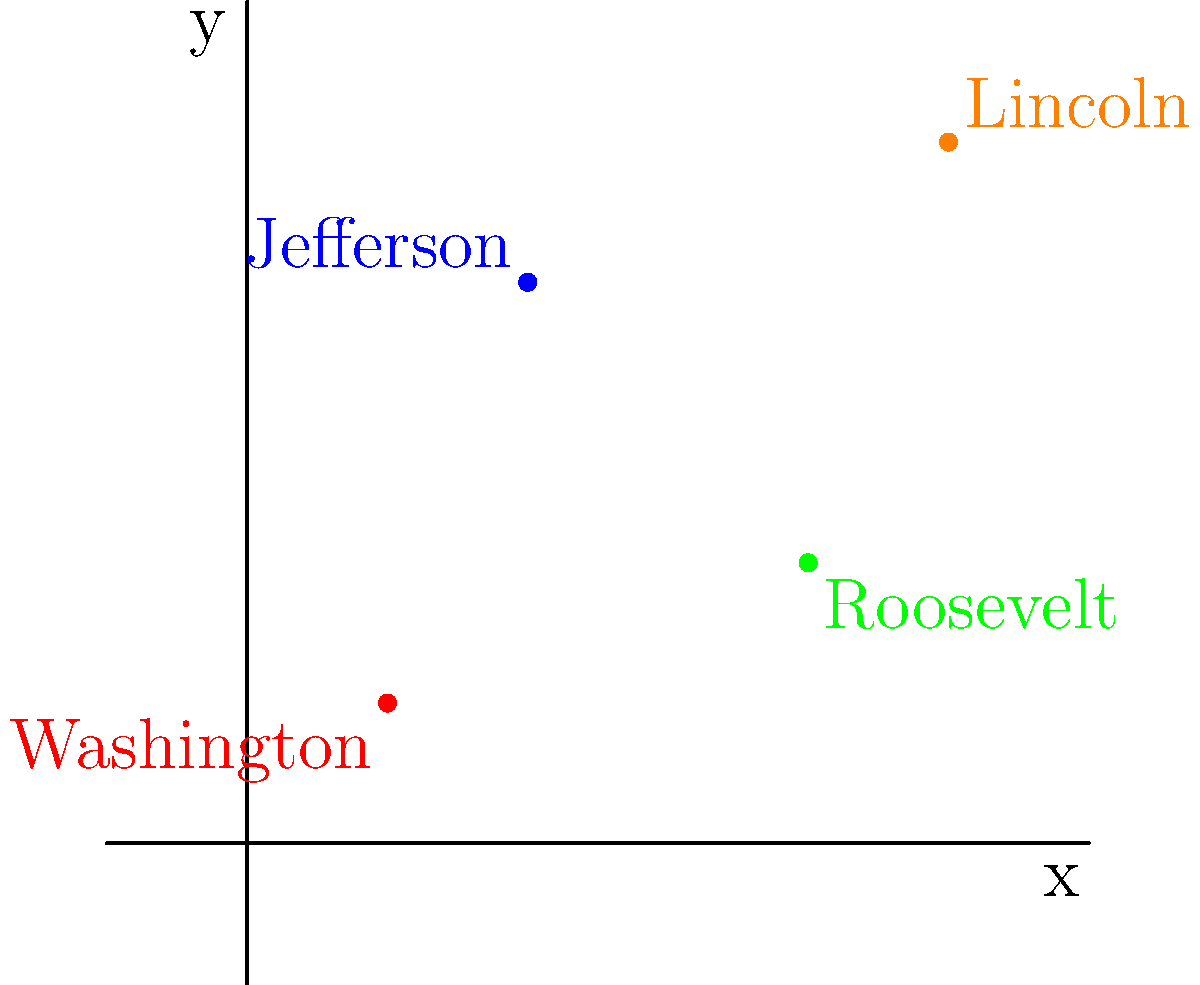In the coordinate system above, four points represent the faces on Mount Rushmore. What is the total distance between Washington's nose (1,1) and Lincoln's nose (5,5)? To find the distance between two points in a coordinate system, we can use the distance formula:

$d = \sqrt{(x_2 - x_1)^2 + (y_2 - y_1)^2}$

Where $(x_1, y_1)$ is the first point and $(x_2, y_2)$ is the second point.

Let's plug in our values:
$(x_1, y_1) = (1, 1)$ for Washington
$(x_2, y_2) = (5, 5)$ for Lincoln

Now, let's calculate:

1) $d = \sqrt{(5 - 1)^2 + (5 - 1)^2}$
2) $d = \sqrt{4^2 + 4^2}$
3) $d = \sqrt{16 + 16}$
4) $d = \sqrt{32}$
5) $d = 4\sqrt{2}$

Therefore, the distance between Washington's nose and Lincoln's nose is $4\sqrt{2}$ units.
Answer: $4\sqrt{2}$ units 